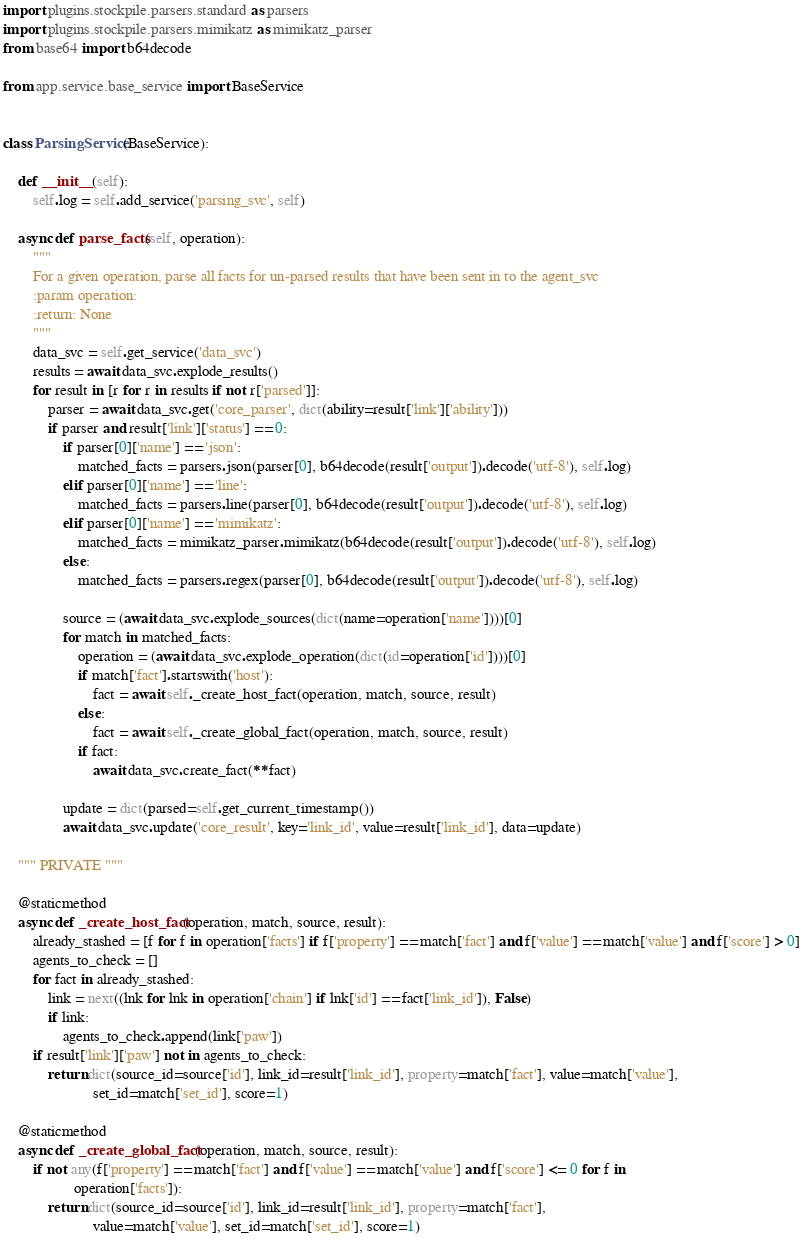Convert code to text. <code><loc_0><loc_0><loc_500><loc_500><_Python_>import plugins.stockpile.parsers.standard as parsers
import plugins.stockpile.parsers.mimikatz as mimikatz_parser
from base64 import b64decode

from app.service.base_service import BaseService


class ParsingService(BaseService):

    def __init__(self):
        self.log = self.add_service('parsing_svc', self)

    async def parse_facts(self, operation):
        """
        For a given operation, parse all facts for un-parsed results that have been sent in to the agent_svc
        :param operation:
        :return: None
        """
        data_svc = self.get_service('data_svc')
        results = await data_svc.explode_results()
        for result in [r for r in results if not r['parsed']]:
            parser = await data_svc.get('core_parser', dict(ability=result['link']['ability']))
            if parser and result['link']['status'] == 0:
                if parser[0]['name'] == 'json':
                    matched_facts = parsers.json(parser[0], b64decode(result['output']).decode('utf-8'), self.log)
                elif parser[0]['name'] == 'line':
                    matched_facts = parsers.line(parser[0], b64decode(result['output']).decode('utf-8'), self.log)
                elif parser[0]['name'] == 'mimikatz':
                    matched_facts = mimikatz_parser.mimikatz(b64decode(result['output']).decode('utf-8'), self.log)
                else:
                    matched_facts = parsers.regex(parser[0], b64decode(result['output']).decode('utf-8'), self.log)

                source = (await data_svc.explode_sources(dict(name=operation['name'])))[0]
                for match in matched_facts:
                    operation = (await data_svc.explode_operation(dict(id=operation['id'])))[0]
                    if match['fact'].startswith('host'):
                        fact = await self._create_host_fact(operation, match, source, result)
                    else:
                        fact = await self._create_global_fact(operation, match, source, result)
                    if fact:
                        await data_svc.create_fact(**fact)

                update = dict(parsed=self.get_current_timestamp())
                await data_svc.update('core_result', key='link_id', value=result['link_id'], data=update)

    """ PRIVATE """

    @staticmethod
    async def _create_host_fact(operation, match, source, result):
        already_stashed = [f for f in operation['facts'] if f['property'] == match['fact'] and f['value'] == match['value'] and f['score'] > 0]
        agents_to_check = []
        for fact in already_stashed:
            link = next((lnk for lnk in operation['chain'] if lnk['id'] == fact['link_id']), False)
            if link:
                agents_to_check.append(link['paw'])
        if result['link']['paw'] not in agents_to_check:
            return dict(source_id=source['id'], link_id=result['link_id'], property=match['fact'], value=match['value'],
                        set_id=match['set_id'], score=1)

    @staticmethod
    async def _create_global_fact(operation, match, source, result):
        if not any(f['property'] == match['fact'] and f['value'] == match['value'] and f['score'] <= 0 for f in
                   operation['facts']):
            return dict(source_id=source['id'], link_id=result['link_id'], property=match['fact'],
                        value=match['value'], set_id=match['set_id'], score=1)
</code> 